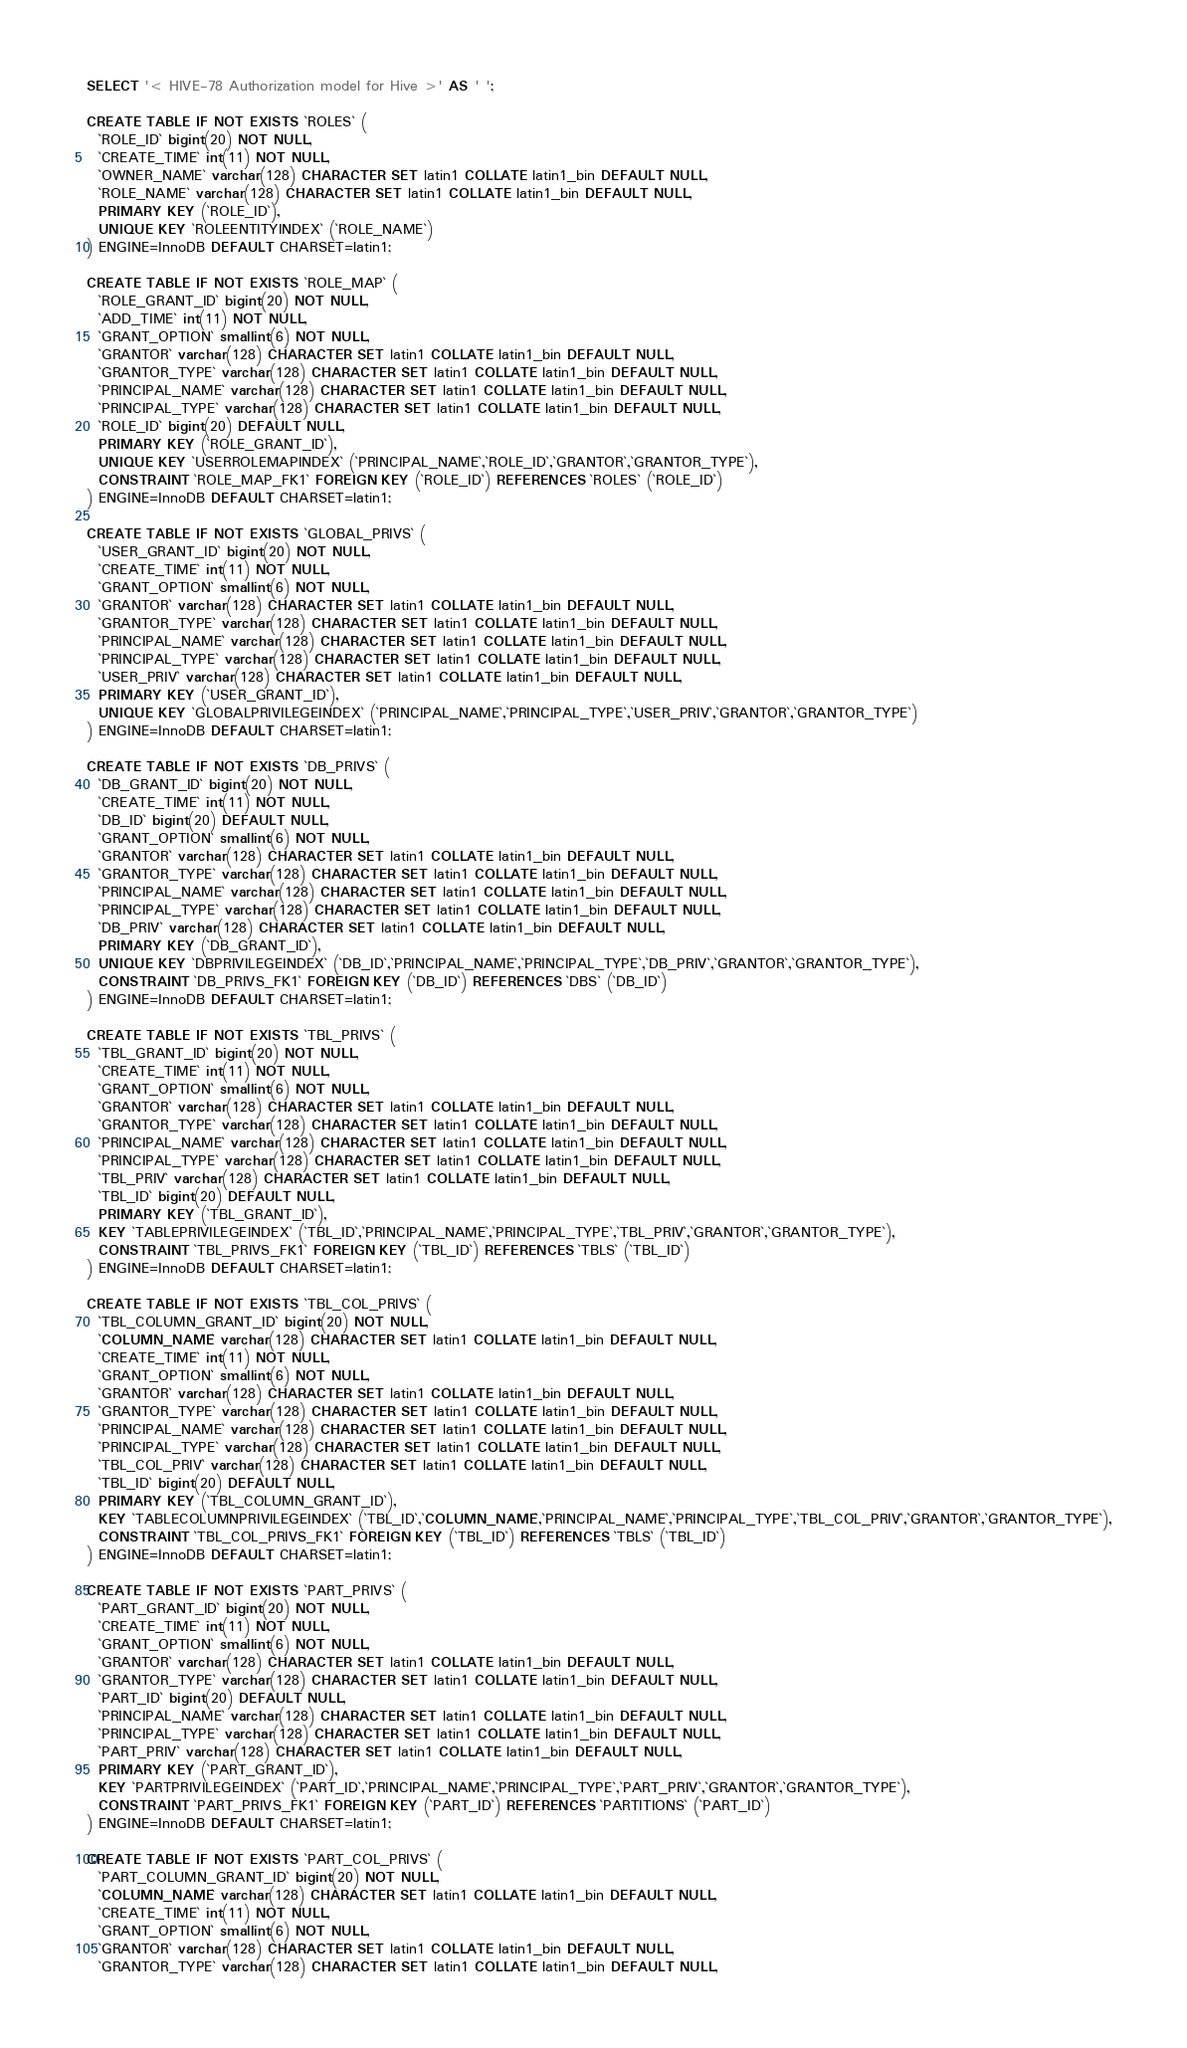Convert code to text. <code><loc_0><loc_0><loc_500><loc_500><_SQL_>SELECT '< HIVE-78 Authorization model for Hive >' AS ' ';

CREATE TABLE IF NOT EXISTS `ROLES` (
  `ROLE_ID` bigint(20) NOT NULL,
  `CREATE_TIME` int(11) NOT NULL,
  `OWNER_NAME` varchar(128) CHARACTER SET latin1 COLLATE latin1_bin DEFAULT NULL,
  `ROLE_NAME` varchar(128) CHARACTER SET latin1 COLLATE latin1_bin DEFAULT NULL,
  PRIMARY KEY (`ROLE_ID`),
  UNIQUE KEY `ROLEENTITYINDEX` (`ROLE_NAME`)
) ENGINE=InnoDB DEFAULT CHARSET=latin1;

CREATE TABLE IF NOT EXISTS `ROLE_MAP` (
  `ROLE_GRANT_ID` bigint(20) NOT NULL,
  `ADD_TIME` int(11) NOT NULL,
  `GRANT_OPTION` smallint(6) NOT NULL,
  `GRANTOR` varchar(128) CHARACTER SET latin1 COLLATE latin1_bin DEFAULT NULL,
  `GRANTOR_TYPE` varchar(128) CHARACTER SET latin1 COLLATE latin1_bin DEFAULT NULL,
  `PRINCIPAL_NAME` varchar(128) CHARACTER SET latin1 COLLATE latin1_bin DEFAULT NULL,
  `PRINCIPAL_TYPE` varchar(128) CHARACTER SET latin1 COLLATE latin1_bin DEFAULT NULL,
  `ROLE_ID` bigint(20) DEFAULT NULL,
  PRIMARY KEY (`ROLE_GRANT_ID`),
  UNIQUE KEY `USERROLEMAPINDEX` (`PRINCIPAL_NAME`,`ROLE_ID`,`GRANTOR`,`GRANTOR_TYPE`),
  CONSTRAINT `ROLE_MAP_FK1` FOREIGN KEY (`ROLE_ID`) REFERENCES `ROLES` (`ROLE_ID`)
) ENGINE=InnoDB DEFAULT CHARSET=latin1;

CREATE TABLE IF NOT EXISTS `GLOBAL_PRIVS` (
  `USER_GRANT_ID` bigint(20) NOT NULL,
  `CREATE_TIME` int(11) NOT NULL,
  `GRANT_OPTION` smallint(6) NOT NULL,
  `GRANTOR` varchar(128) CHARACTER SET latin1 COLLATE latin1_bin DEFAULT NULL,
  `GRANTOR_TYPE` varchar(128) CHARACTER SET latin1 COLLATE latin1_bin DEFAULT NULL,
  `PRINCIPAL_NAME` varchar(128) CHARACTER SET latin1 COLLATE latin1_bin DEFAULT NULL,
  `PRINCIPAL_TYPE` varchar(128) CHARACTER SET latin1 COLLATE latin1_bin DEFAULT NULL,
  `USER_PRIV` varchar(128) CHARACTER SET latin1 COLLATE latin1_bin DEFAULT NULL,
  PRIMARY KEY (`USER_GRANT_ID`),
  UNIQUE KEY `GLOBALPRIVILEGEINDEX` (`PRINCIPAL_NAME`,`PRINCIPAL_TYPE`,`USER_PRIV`,`GRANTOR`,`GRANTOR_TYPE`)
) ENGINE=InnoDB DEFAULT CHARSET=latin1;

CREATE TABLE IF NOT EXISTS `DB_PRIVS` (
  `DB_GRANT_ID` bigint(20) NOT NULL,
  `CREATE_TIME` int(11) NOT NULL,
  `DB_ID` bigint(20) DEFAULT NULL,
  `GRANT_OPTION` smallint(6) NOT NULL,
  `GRANTOR` varchar(128) CHARACTER SET latin1 COLLATE latin1_bin DEFAULT NULL,
  `GRANTOR_TYPE` varchar(128) CHARACTER SET latin1 COLLATE latin1_bin DEFAULT NULL,
  `PRINCIPAL_NAME` varchar(128) CHARACTER SET latin1 COLLATE latin1_bin DEFAULT NULL,
  `PRINCIPAL_TYPE` varchar(128) CHARACTER SET latin1 COLLATE latin1_bin DEFAULT NULL,
  `DB_PRIV` varchar(128) CHARACTER SET latin1 COLLATE latin1_bin DEFAULT NULL,
  PRIMARY KEY (`DB_GRANT_ID`),
  UNIQUE KEY `DBPRIVILEGEINDEX` (`DB_ID`,`PRINCIPAL_NAME`,`PRINCIPAL_TYPE`,`DB_PRIV`,`GRANTOR`,`GRANTOR_TYPE`),
  CONSTRAINT `DB_PRIVS_FK1` FOREIGN KEY (`DB_ID`) REFERENCES `DBS` (`DB_ID`)
) ENGINE=InnoDB DEFAULT CHARSET=latin1;

CREATE TABLE IF NOT EXISTS `TBL_PRIVS` (
  `TBL_GRANT_ID` bigint(20) NOT NULL,
  `CREATE_TIME` int(11) NOT NULL,
  `GRANT_OPTION` smallint(6) NOT NULL,
  `GRANTOR` varchar(128) CHARACTER SET latin1 COLLATE latin1_bin DEFAULT NULL,
  `GRANTOR_TYPE` varchar(128) CHARACTER SET latin1 COLLATE latin1_bin DEFAULT NULL,
  `PRINCIPAL_NAME` varchar(128) CHARACTER SET latin1 COLLATE latin1_bin DEFAULT NULL,
  `PRINCIPAL_TYPE` varchar(128) CHARACTER SET latin1 COLLATE latin1_bin DEFAULT NULL,
  `TBL_PRIV` varchar(128) CHARACTER SET latin1 COLLATE latin1_bin DEFAULT NULL,
  `TBL_ID` bigint(20) DEFAULT NULL,
  PRIMARY KEY (`TBL_GRANT_ID`),
  KEY `TABLEPRIVILEGEINDEX` (`TBL_ID`,`PRINCIPAL_NAME`,`PRINCIPAL_TYPE`,`TBL_PRIV`,`GRANTOR`,`GRANTOR_TYPE`),
  CONSTRAINT `TBL_PRIVS_FK1` FOREIGN KEY (`TBL_ID`) REFERENCES `TBLS` (`TBL_ID`)
) ENGINE=InnoDB DEFAULT CHARSET=latin1;

CREATE TABLE IF NOT EXISTS `TBL_COL_PRIVS` (
  `TBL_COLUMN_GRANT_ID` bigint(20) NOT NULL,
  `COLUMN_NAME` varchar(128) CHARACTER SET latin1 COLLATE latin1_bin DEFAULT NULL,
  `CREATE_TIME` int(11) NOT NULL,
  `GRANT_OPTION` smallint(6) NOT NULL,
  `GRANTOR` varchar(128) CHARACTER SET latin1 COLLATE latin1_bin DEFAULT NULL,
  `GRANTOR_TYPE` varchar(128) CHARACTER SET latin1 COLLATE latin1_bin DEFAULT NULL,
  `PRINCIPAL_NAME` varchar(128) CHARACTER SET latin1 COLLATE latin1_bin DEFAULT NULL,
  `PRINCIPAL_TYPE` varchar(128) CHARACTER SET latin1 COLLATE latin1_bin DEFAULT NULL,
  `TBL_COL_PRIV` varchar(128) CHARACTER SET latin1 COLLATE latin1_bin DEFAULT NULL,
  `TBL_ID` bigint(20) DEFAULT NULL,
  PRIMARY KEY (`TBL_COLUMN_GRANT_ID`),
  KEY `TABLECOLUMNPRIVILEGEINDEX` (`TBL_ID`,`COLUMN_NAME`,`PRINCIPAL_NAME`,`PRINCIPAL_TYPE`,`TBL_COL_PRIV`,`GRANTOR`,`GRANTOR_TYPE`),
  CONSTRAINT `TBL_COL_PRIVS_FK1` FOREIGN KEY (`TBL_ID`) REFERENCES `TBLS` (`TBL_ID`)
) ENGINE=InnoDB DEFAULT CHARSET=latin1;

CREATE TABLE IF NOT EXISTS `PART_PRIVS` (
  `PART_GRANT_ID` bigint(20) NOT NULL,
  `CREATE_TIME` int(11) NOT NULL,
  `GRANT_OPTION` smallint(6) NOT NULL,
  `GRANTOR` varchar(128) CHARACTER SET latin1 COLLATE latin1_bin DEFAULT NULL,
  `GRANTOR_TYPE` varchar(128) CHARACTER SET latin1 COLLATE latin1_bin DEFAULT NULL,
  `PART_ID` bigint(20) DEFAULT NULL,
  `PRINCIPAL_NAME` varchar(128) CHARACTER SET latin1 COLLATE latin1_bin DEFAULT NULL,
  `PRINCIPAL_TYPE` varchar(128) CHARACTER SET latin1 COLLATE latin1_bin DEFAULT NULL,
  `PART_PRIV` varchar(128) CHARACTER SET latin1 COLLATE latin1_bin DEFAULT NULL,
  PRIMARY KEY (`PART_GRANT_ID`),
  KEY `PARTPRIVILEGEINDEX` (`PART_ID`,`PRINCIPAL_NAME`,`PRINCIPAL_TYPE`,`PART_PRIV`,`GRANTOR`,`GRANTOR_TYPE`),
  CONSTRAINT `PART_PRIVS_FK1` FOREIGN KEY (`PART_ID`) REFERENCES `PARTITIONS` (`PART_ID`)
) ENGINE=InnoDB DEFAULT CHARSET=latin1;

CREATE TABLE IF NOT EXISTS `PART_COL_PRIVS` (
  `PART_COLUMN_GRANT_ID` bigint(20) NOT NULL,
  `COLUMN_NAME` varchar(128) CHARACTER SET latin1 COLLATE latin1_bin DEFAULT NULL,
  `CREATE_TIME` int(11) NOT NULL,
  `GRANT_OPTION` smallint(6) NOT NULL,
  `GRANTOR` varchar(128) CHARACTER SET latin1 COLLATE latin1_bin DEFAULT NULL,
  `GRANTOR_TYPE` varchar(128) CHARACTER SET latin1 COLLATE latin1_bin DEFAULT NULL,</code> 